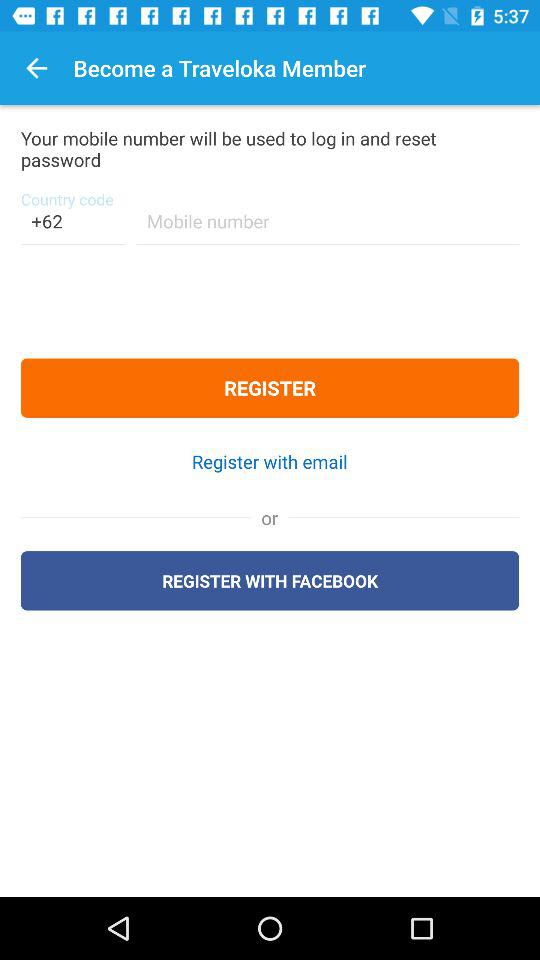What application is advised to become a member? The application is "Traveloka". 